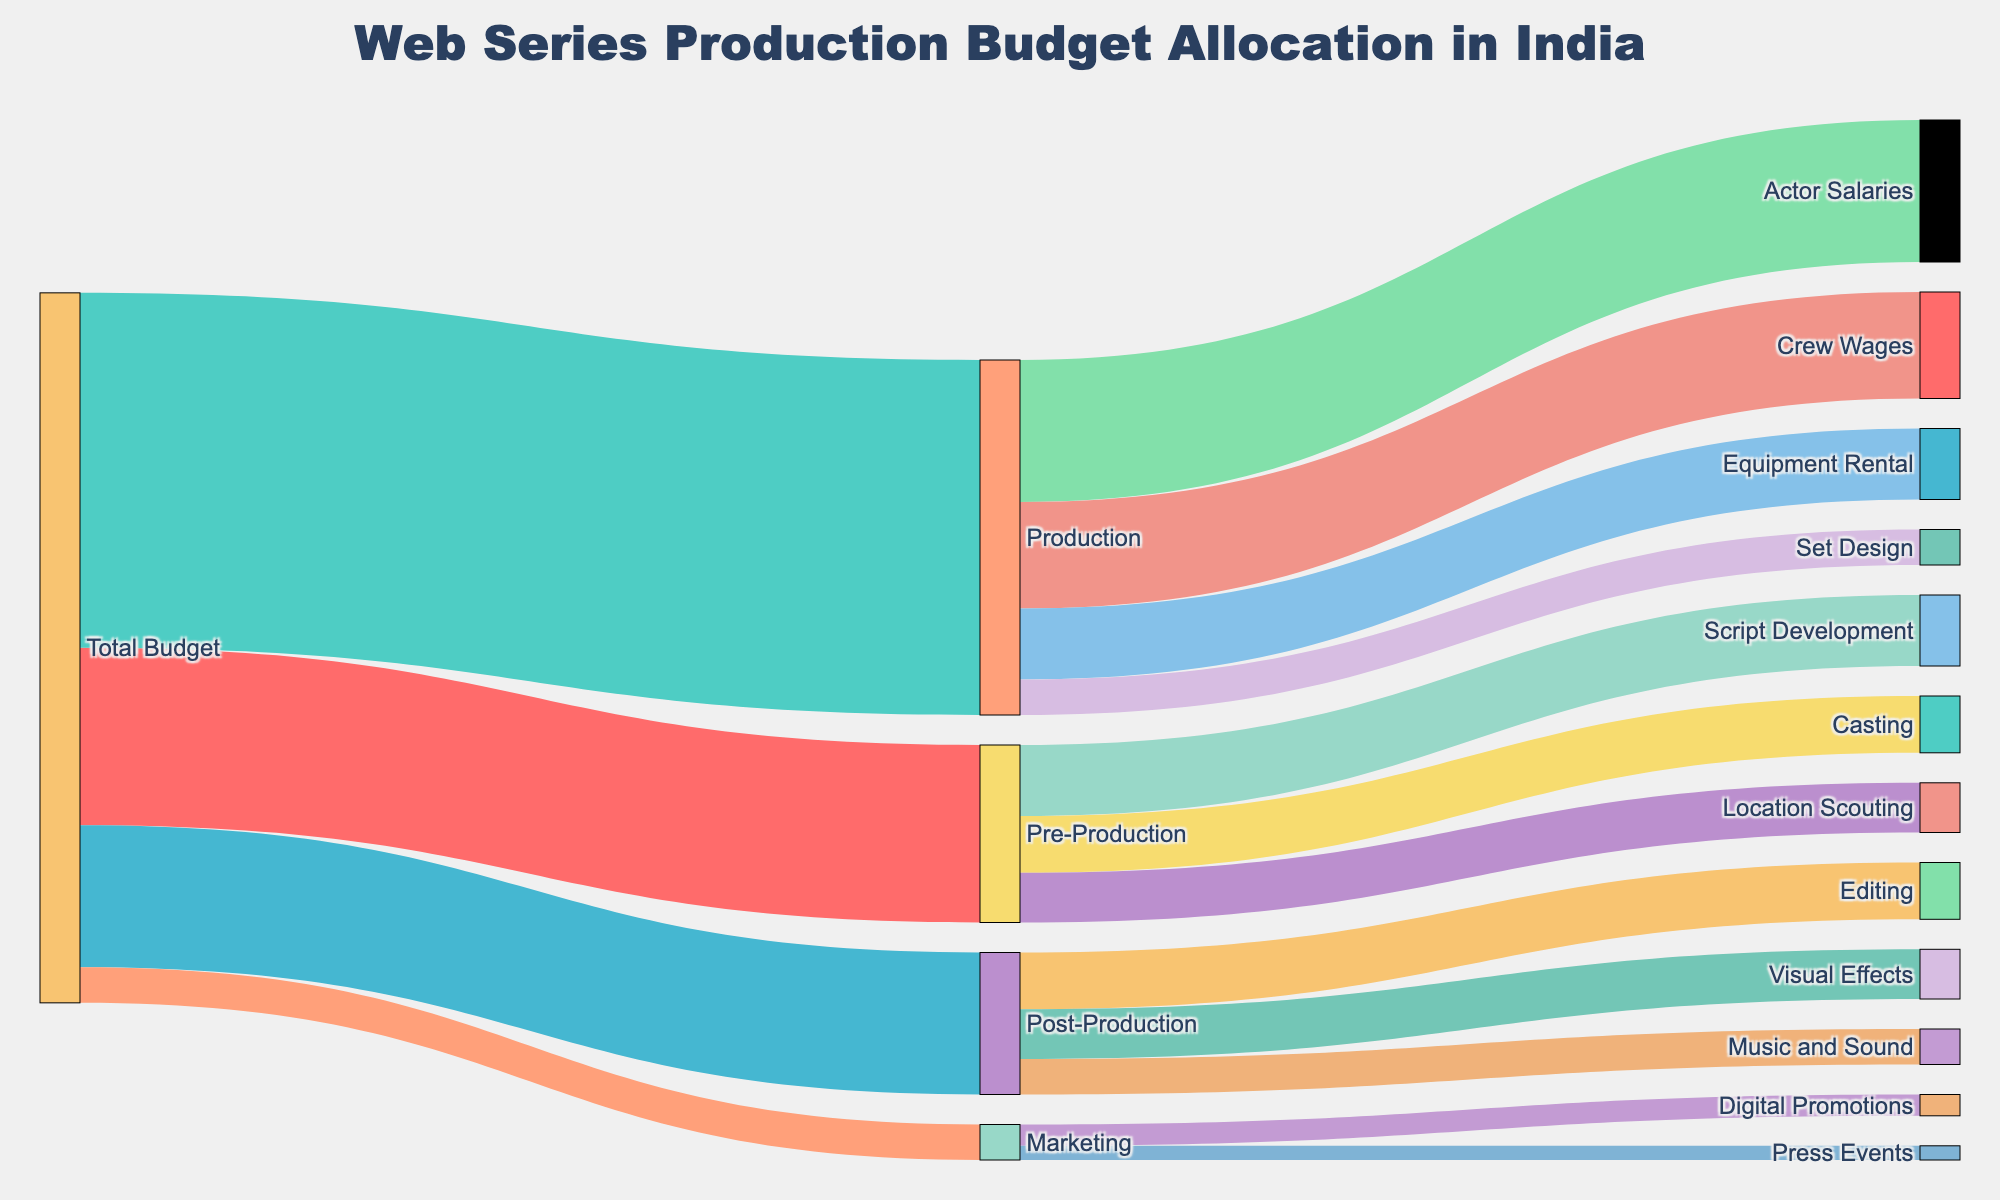What is the title of the Sankey diagram? The title is typically the most prominent text at the top of the figure. In this case, the title is centered at the top and clearly states the main subject.
Answer: "Web Series Production Budget Allocation in India" Which section of the budget gets the largest allocation? In the Sankey diagram, the width of the flows represents the magnitude of the allocation. The largest flow connected to "Total Budget" indicates the largest allocation.
Answer: Production How much budget is allocated to Marketing? Follow the flow from "Total Budget" to "Marketing" to view the value shown.
Answer: 5 What is the total budget allocated to Pre-Production? Examine all the flows that connect to "Pre-Production" from "Total Budget", which show the segmented allocations, then sum them up.
Answer: 25 How does the budget for Actor Salaries compare to Crew Wages during Production? Compare the flow values from "Production" to "Actor Salaries" and to "Crew Wages".
Answer: Actor Salaries: 20, Crew Wages: 15, Actor Salaries > Crew Wages What is the combined budget for Editing and Visual Effects in Post-Production? Sum the individual allocations from "Post-Production" to "Editing" and "Visual Effects".
Answer: Editing: 8 + Visual Effects: 7 = 15 Which category within Pre-Production has the smallest budget? Identify the flow from "Pre-Production" to all its sub-categories and find the smallest value.
Answer: Location Scouting What is the total amount allocated to different categories within Post-Production? Sum all the values flowing from "Post-Production" to its sub-categories.
Answer: Editing: 8 + Visual Effects: 7 + Music and Sound: 5 = 20 What proportion of the total budget is dedicated to Production compared to Post-Production? Calculate the ratio of the budget allocated to Production and Post-Production, then simplify the ratio.
Answer: Production: 50/Total Budget: 100, Post-Production: 20/Total Budget: 100, so 50:20 = 5:2 Is the budget allocated to Digital Promotions greater than the budget for Press Events? Compare the flow values for "Digital Promotions" and "Press Events" within the Marketing category.
Answer: Yes, Digital Promotions: 3, Press Events: 2 